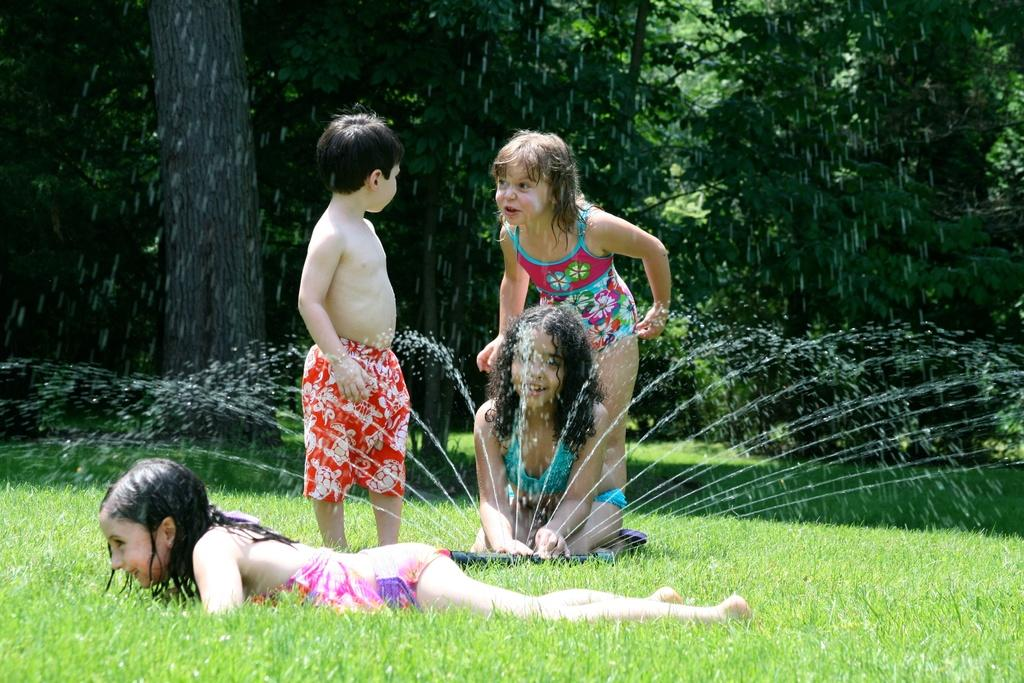How many kids are in the image? There are four kids in the foreground of the image. What is the surface the kids are standing on? The kids are on grass. What else can be seen in the foreground of the image? There is water visible in the foreground, as well as an unspecified object. What is visible in the background of the image? There are trees in the background of the image. Can you describe the time of day when the image was taken? The image appears to be taken during the day. What type of gold jewelry is the monkey wearing in the image? There is no monkey or gold jewelry present in the image. How many fowl can be seen in the image? There are no fowl visible in the image. 